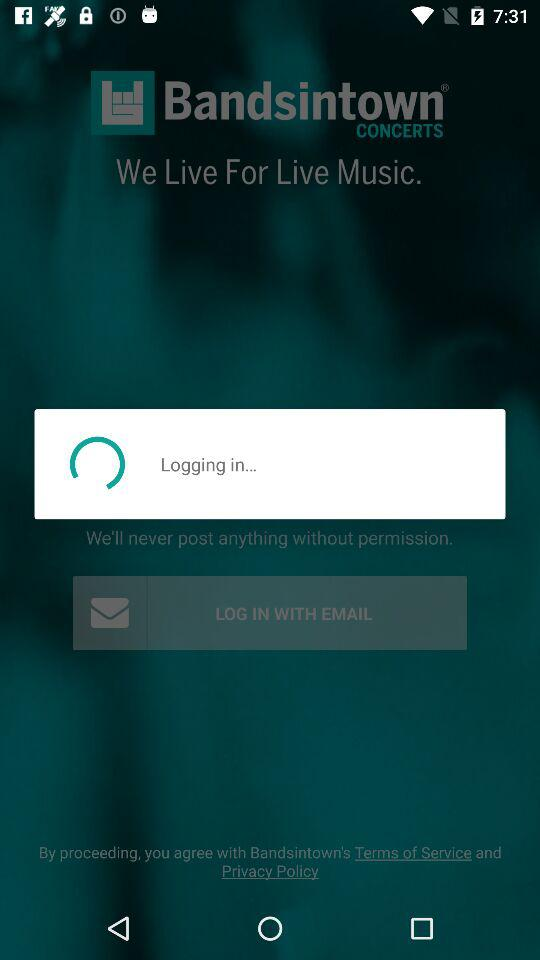What are the log in options? The log in options are "FACEBOOK" and "EMAIL". 